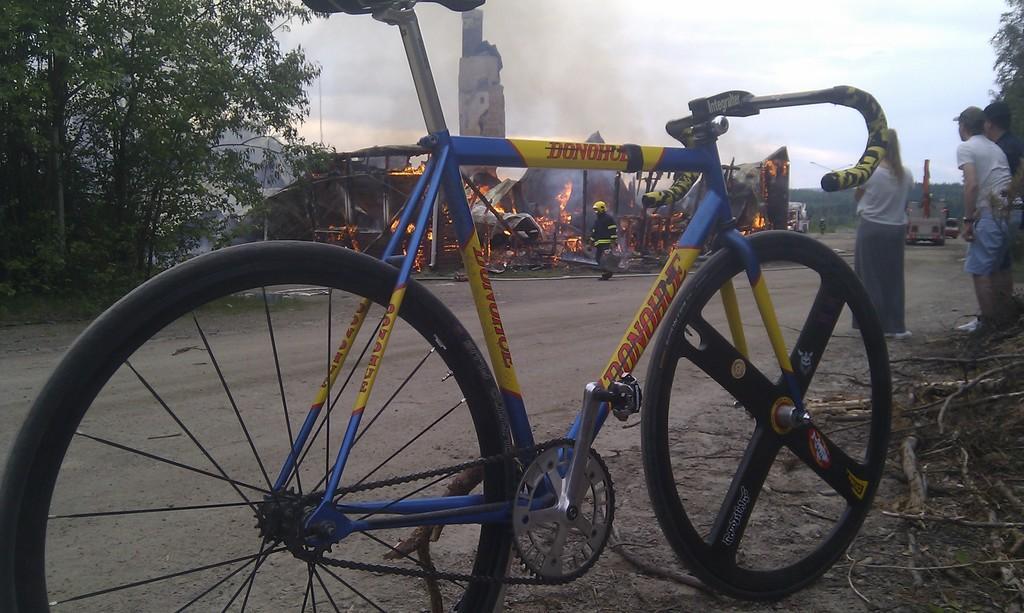In one or two sentences, can you explain what this image depicts? There is a bicycle in the foreground. In the right few people are standing. In the background there are trees, a building is on fire. Few firemen are at the place. There is smoke in the sky. Few vehicles are moving on the road. 